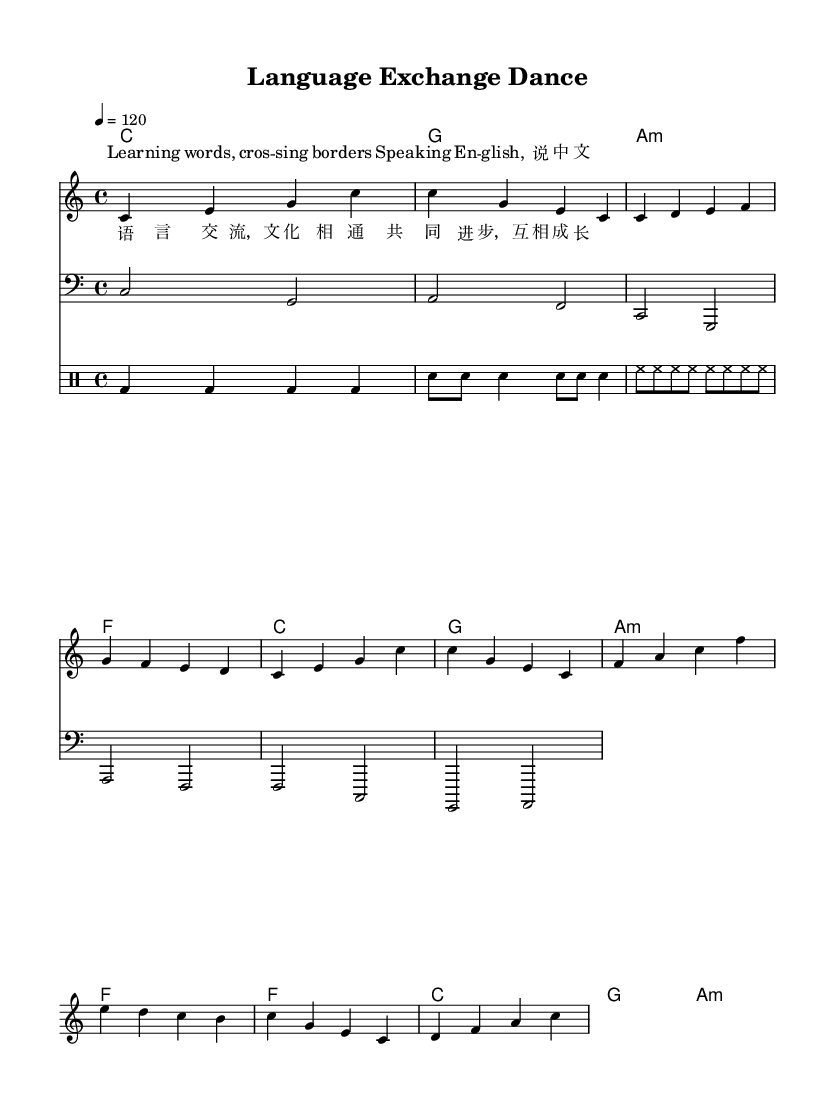What is the key signature of this music? The key signature is C major, which has no sharps or flats.
Answer: C major What is the time signature of the piece? The time signature is found at the beginning of the score and is indicated as 4/4, which means there are four beats per measure.
Answer: 4/4 What is the tempo marking for this piece? The tempo marking is shown at the beginning of the score as "4 = 120," indicating that the quarter note is played at 120 beats per minute.
Answer: 120 How many verses are in this dance track? The lyrics section contains two distinct verses labeled "verseOneWords" and "verseTwoWords," indicating that there are two verses in total.
Answer: Two What languages are featured in the lyrics? The lyrics include phrases in both English and Chinese, as indicated by the alternating lines in the lyrics.
Answer: English and Chinese What type of musical section follows the verses? The sheet music outlines a structured format with a chorus indicated after the verses, which usually serves as a repeated refrain.
Answer: Chorus 